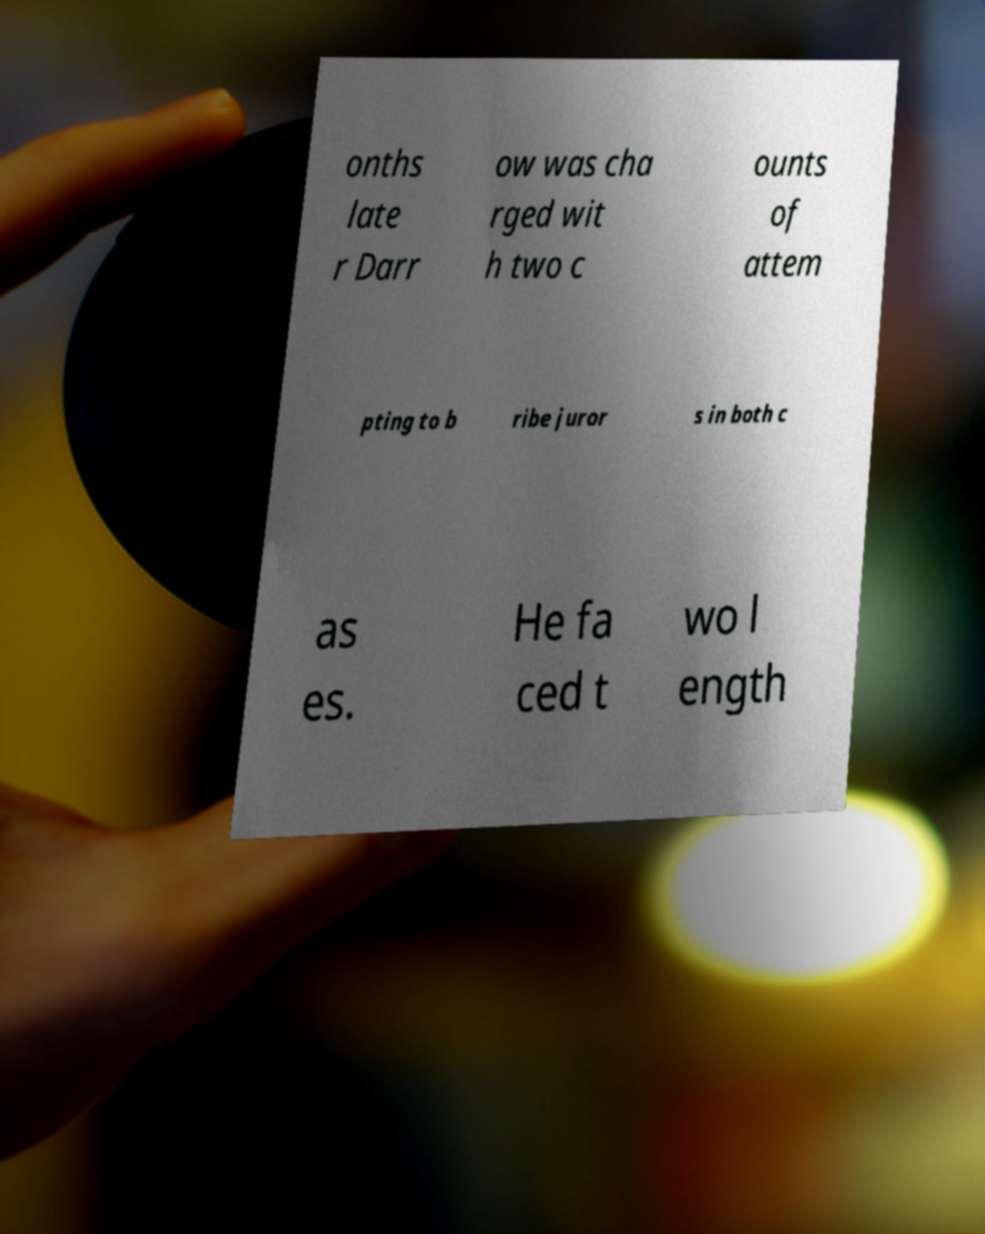Please read and relay the text visible in this image. What does it say? onths late r Darr ow was cha rged wit h two c ounts of attem pting to b ribe juror s in both c as es. He fa ced t wo l ength 